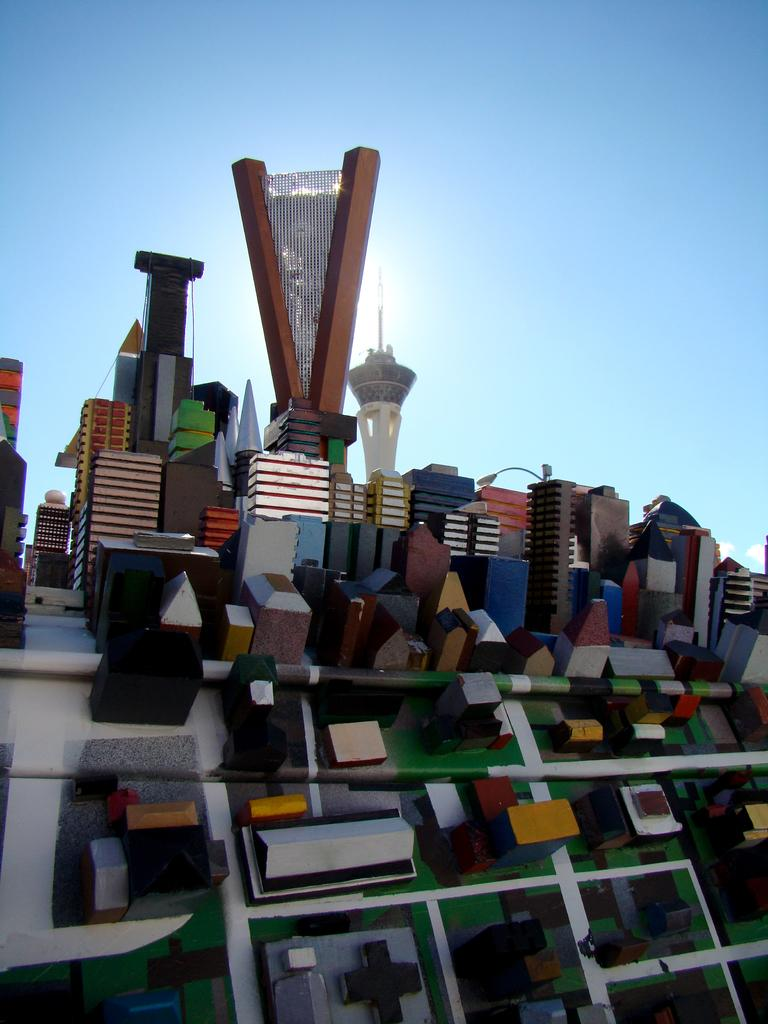What type of image is being depicted in the picture? The image appears to be a miniature. What can be seen within the miniature? There are different structures in the miniature. What is visible at the top of the image? The sky is visible at the top of the image. What type of party is being held in the miniature? There is no indication of a party in the miniature; it simply depicts different structures. What arithmetic problem can be solved using the liquid in the miniature? There is no liquid present in the miniature, so no arithmetic problem can be solved using it. 